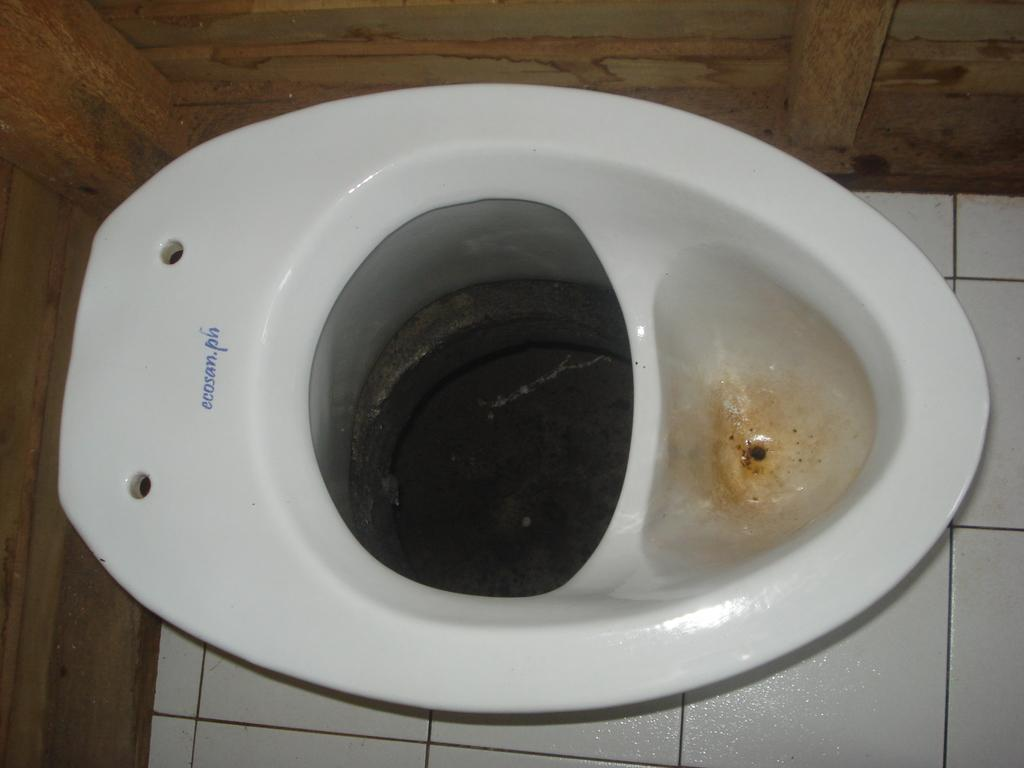What object is placed on the floor in the image? There is a toilet on the floor in the image. What type of material is used for the wall in the image? The wall in the image is made of wood. What is the cause of the rapid growth in the image? There is no indication of growth or any cause for it in the image, as it only features a toilet and a wooden wall. 